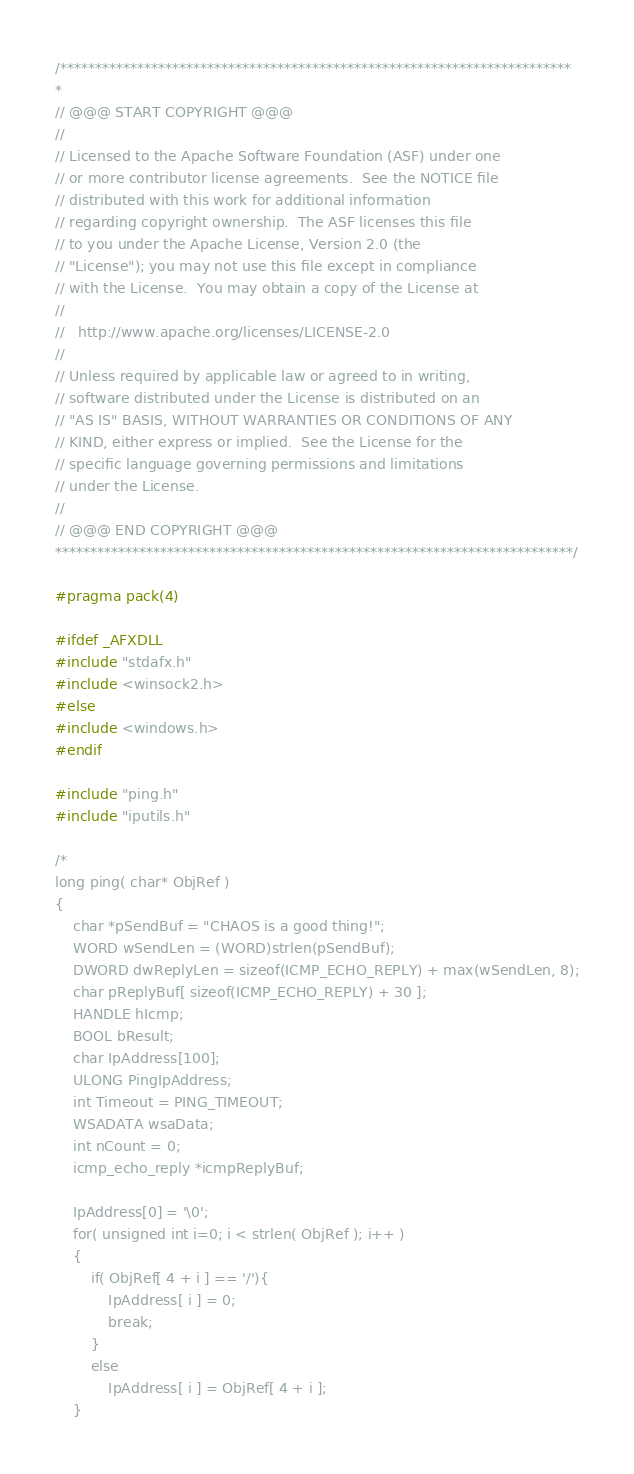<code> <loc_0><loc_0><loc_500><loc_500><_C++_>/*************************************************************************
*
// @@@ START COPYRIGHT @@@
//
// Licensed to the Apache Software Foundation (ASF) under one
// or more contributor license agreements.  See the NOTICE file
// distributed with this work for additional information
// regarding copyright ownership.  The ASF licenses this file
// to you under the Apache License, Version 2.0 (the
// "License"); you may not use this file except in compliance
// with the License.  You may obtain a copy of the License at
//
//   http://www.apache.org/licenses/LICENSE-2.0
//
// Unless required by applicable law or agreed to in writing,
// software distributed under the License is distributed on an
// "AS IS" BASIS, WITHOUT WARRANTIES OR CONDITIONS OF ANY
// KIND, either express or implied.  See the License for the
// specific language governing permissions and limitations
// under the License.
//
// @@@ END COPYRIGHT @@@
**************************************************************************/

#pragma pack(4)

#ifdef _AFXDLL
#include "stdafx.h"
#include <winsock2.h>
#else
#include <windows.h>
#endif

#include "ping.h"
#include "iputils.h"

/*
long ping( char* ObjRef )
{
	char *pSendBuf = "CHAOS is a good thing!";
	WORD wSendLen = (WORD)strlen(pSendBuf);
	DWORD dwReplyLen = sizeof(ICMP_ECHO_REPLY) + max(wSendLen, 8);
	char pReplyBuf[ sizeof(ICMP_ECHO_REPLY) + 30 ];
	HANDLE hIcmp;
	BOOL bResult;
	char IpAddress[100];
	ULONG PingIpAddress;
	int Timeout = PING_TIMEOUT; 
	WSADATA wsaData; 
	int nCount = 0;
	icmp_echo_reply	*icmpReplyBuf;

	IpAddress[0] = '\0';
	for( unsigned int i=0; i < strlen( ObjRef ); i++ )
	{
		if( ObjRef[ 4 + i ] == '/'){
			IpAddress[ i ] = 0;
			break;
		}
		else
			IpAddress[ i ] = ObjRef[ 4 + i ];
	}
</code> 